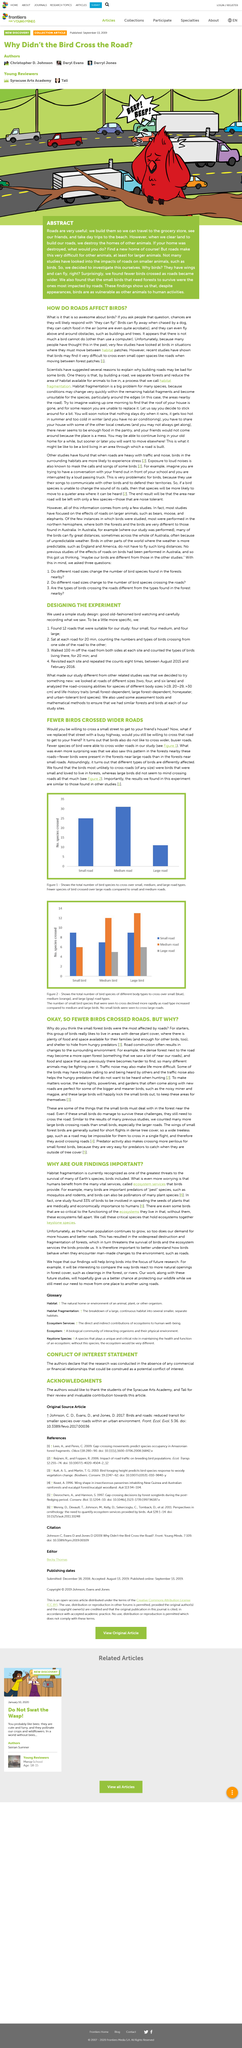Highlight a few significant elements in this photo. What makes matters worse is the installation of new lights, powerlines, and gardens, which exacerbates the discomfort caused by the headwinds and raindrops. Small birds typically reside in locations with abundant vegetation, such as forests, gardens, and parks. Habitat fragmentation is a significant problem for a large number of species, posing a threat to their survival. Yes, recent studies have shown that birds may find it challenging to navigate across small open spaces, such as roads. Birds can indeed fly away when being chased by a dog. 